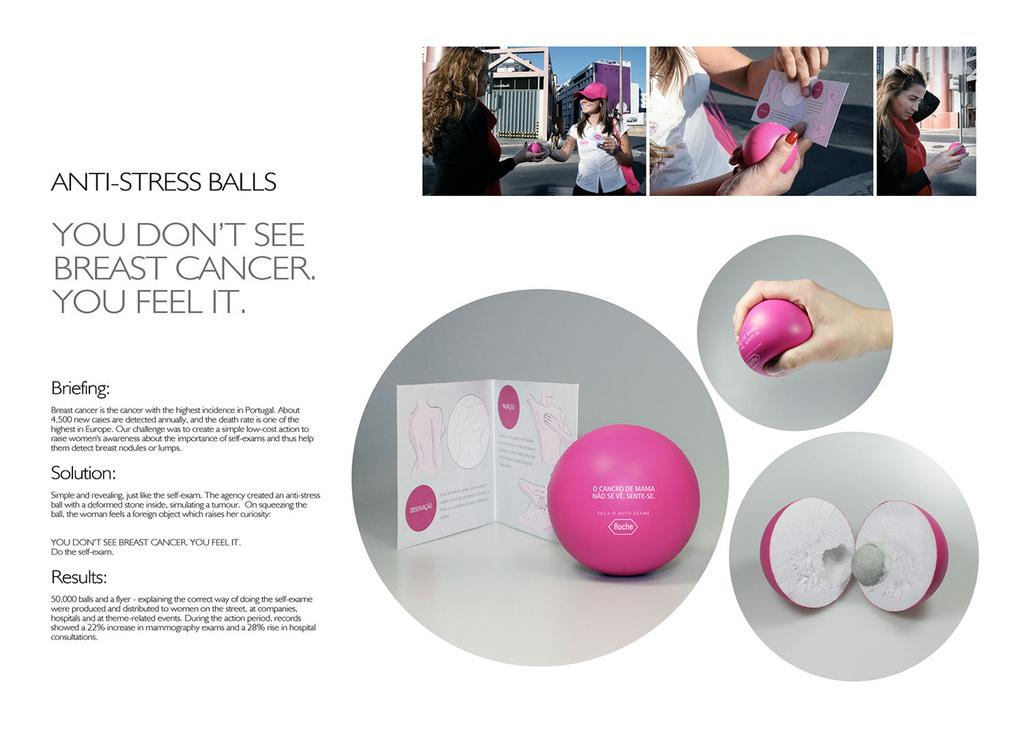What is the main object in the image? There is a slide in the image. What can be found on the slide? The slide contains different collages of photos. Are there any words or phrases on the slide? Yes, there is text present on the slide. How does the slide blow air onto the photos? The slide does not blow air onto the photos; it is a stationary object with collages of photos and text. 